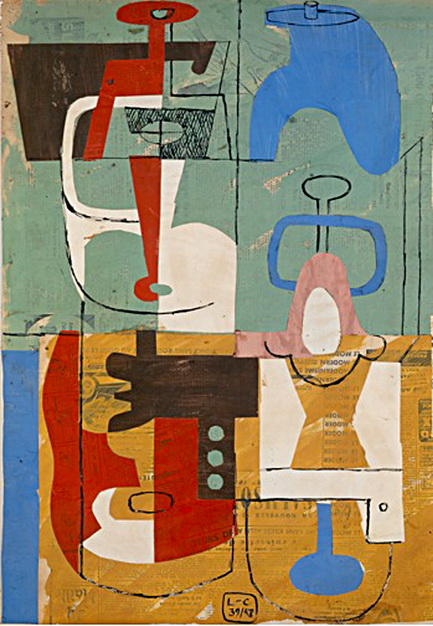Imagine this abstract artwork is a map to a fantastical world. Describe this world in detail. In this fantastical world, the vibrant colors of the artwork translate into lush landscapes and vibrant cities. The blue areas represent vast, shimmering oceans and clear skies, while the reds and oranges depict fiery mountains and thriving forests. The geometric shapes transform into intricate architectures and elaborate pathways that weave through this imagined realm.

The world is divided into unique regions, each with its own distinct culture and environment. The textured background hints at the rich history and ancient civilizations that once thrived here, leaving behind a legacy of wisdom and wonder. The lines and curves within the artwork become rivers and roads, connecting the different regions and facilitating the exchange of ideas and resources.

Inhabitants of this world are as diverse as the colors on the canvas, with each group contributing to the harmony and balance of the entire realm. This fantastical world is a place of endless exploration and adventure, where the beauty of the natural and artificial seamlessly blend to create a breathtaking symphony of existence. 